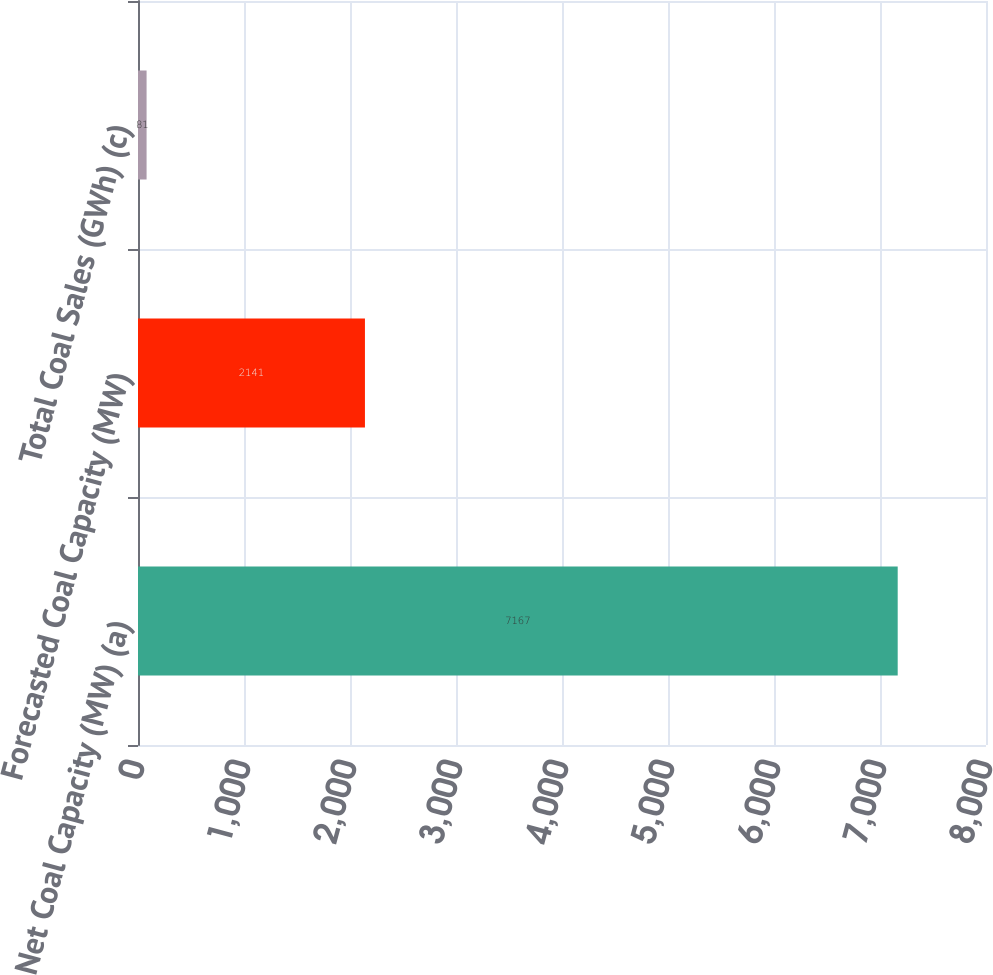Convert chart to OTSL. <chart><loc_0><loc_0><loc_500><loc_500><bar_chart><fcel>Net Coal Capacity (MW) (a)<fcel>Forecasted Coal Capacity (MW)<fcel>Total Coal Sales (GWh) (c)<nl><fcel>7167<fcel>2141<fcel>81<nl></chart> 